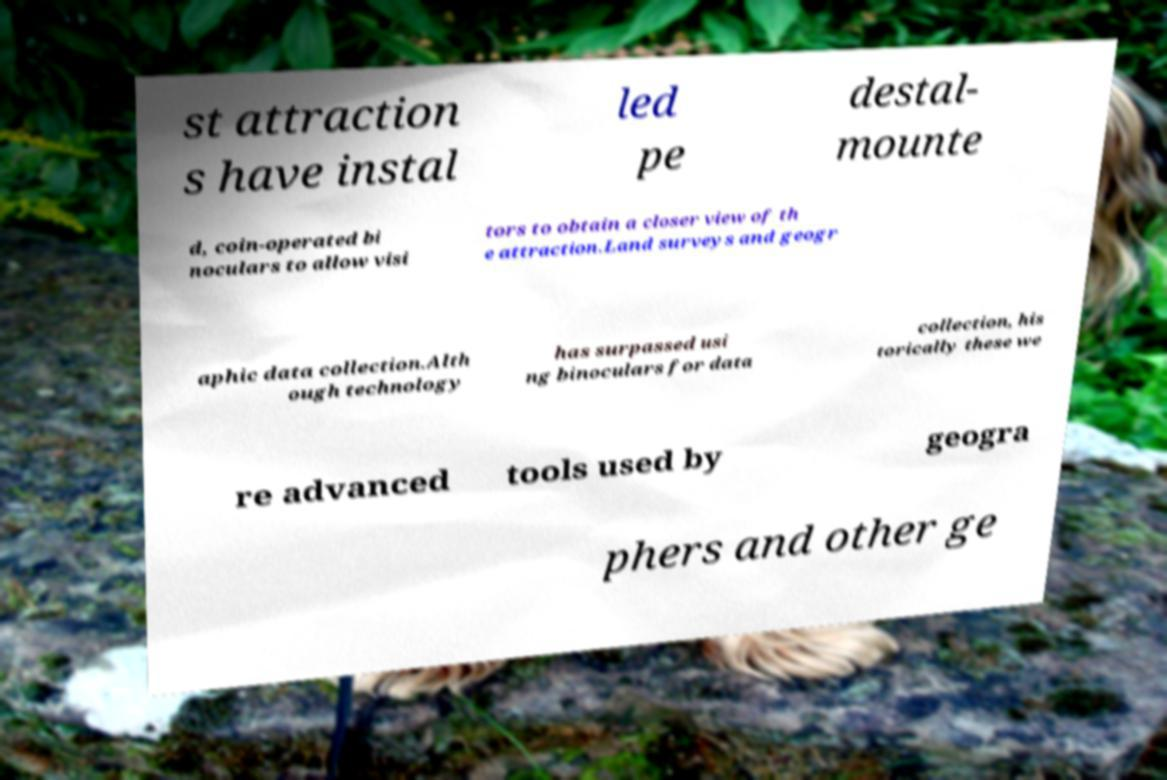There's text embedded in this image that I need extracted. Can you transcribe it verbatim? st attraction s have instal led pe destal- mounte d, coin-operated bi noculars to allow visi tors to obtain a closer view of th e attraction.Land surveys and geogr aphic data collection.Alth ough technology has surpassed usi ng binoculars for data collection, his torically these we re advanced tools used by geogra phers and other ge 